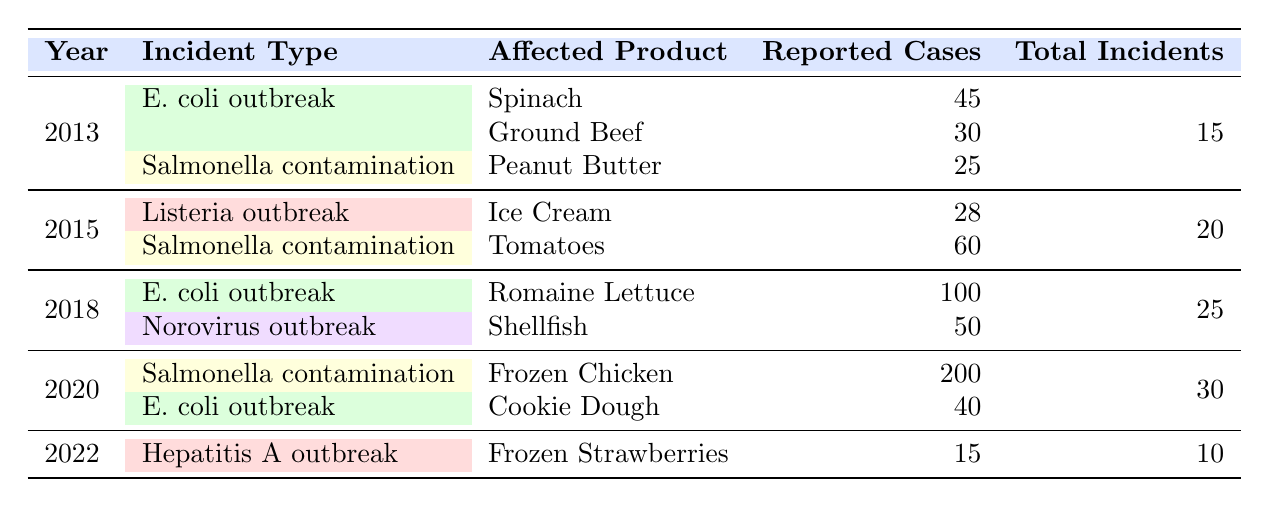What was the total number of food safety incidents reported in 2018? The table indicates that the total incidents for the year 2018 is listed under the "Total Incidents" column, which shows a value of 25.
Answer: 25 Which product had the highest reported cases in 2020? In the year 2020, the table reveals that the product "Frozen Chicken" had 200 reported cases, which is more than any other product listed for that year.
Answer: Frozen Chicken Did the total number of incidents increase from 2015 to 2020? Comparing the total incidents for 2015 (20) and 2020 (30) shows an increase, meaning that the total number of incidents rose by 10 incidents over this period.
Answer: Yes What is the sum of reported cases for all products affected by E. coli outbreaks? The table lists E. coli outbreak cases: in 2013, there were 45 (Spinach) and 30 (Ground Beef); in 2018, there were 100 (Romaine Lettuce); in 2020, there were 40 (Cookie Dough). Summing these gives 45 + 30 + 100 + 40 = 215 reported cases.
Answer: 215 Is there any type of incident that occurred in only one year according to the table? The table indicates that the "Hepatitis A outbreak" in 2022 occurred as a single type of incident for that year, with no other incident reported in 2022.
Answer: Yes What was the average number of reported cases for Salmonella contamination incidents from 2015 to 2020? In the specified years, the reported cases for Salmonella were 60 (2015 - Tomatoes) and 200 (2020 - Frozen Chicken). The average for these two incidents is calculated as (60 + 200) / 2 = 130.
Answer: 130 How many different types of incidents were reported in total across all years? By examining the types listed for each year in the table, we find 5 unique incident types: E. coli outbreak, Salmonella contamination, Listeria outbreak, Norovirus outbreak, and Hepatitis A outbreak. Therefore, the total count is 5 types.
Answer: 5 Which year had the lowest total number of reported incidents? The lowest total incidents are found in 2022 with only 10 reported incidents, as noted in the "Total Incidents" column.
Answer: 2022 What was the percentage of reported cases due to E. coli outbreaks in 2018 compared to the total incidents that year? In 2018, E. coli outbreak cases totaled 100 (Romaine Lettuce), with a total incident count of 25, so the percentage is calculated as (100/25) * 100% = 400%.
Answer: 400% 